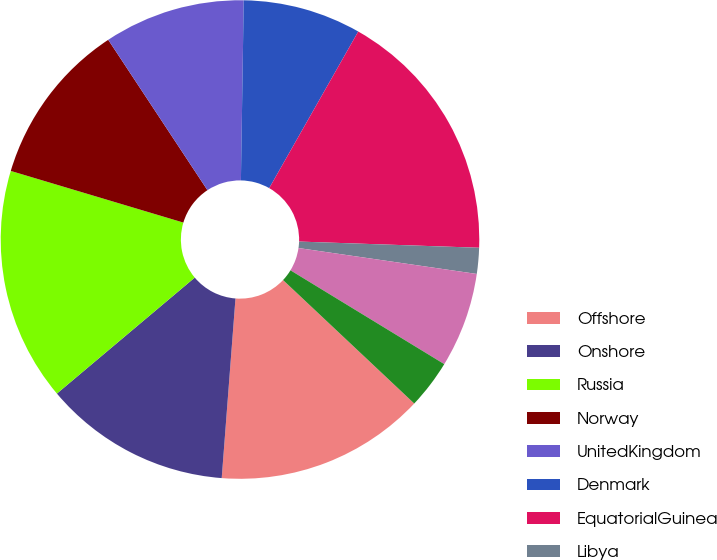Convert chart to OTSL. <chart><loc_0><loc_0><loc_500><loc_500><pie_chart><fcel>Offshore<fcel>Onshore<fcel>Russia<fcel>Norway<fcel>UnitedKingdom<fcel>Denmark<fcel>EquatorialGuinea<fcel>Libya<fcel>Algeria<fcel>Azerbaijan<nl><fcel>14.2%<fcel>12.65%<fcel>15.76%<fcel>11.09%<fcel>9.53%<fcel>7.98%<fcel>17.32%<fcel>1.75%<fcel>6.42%<fcel>3.3%<nl></chart> 